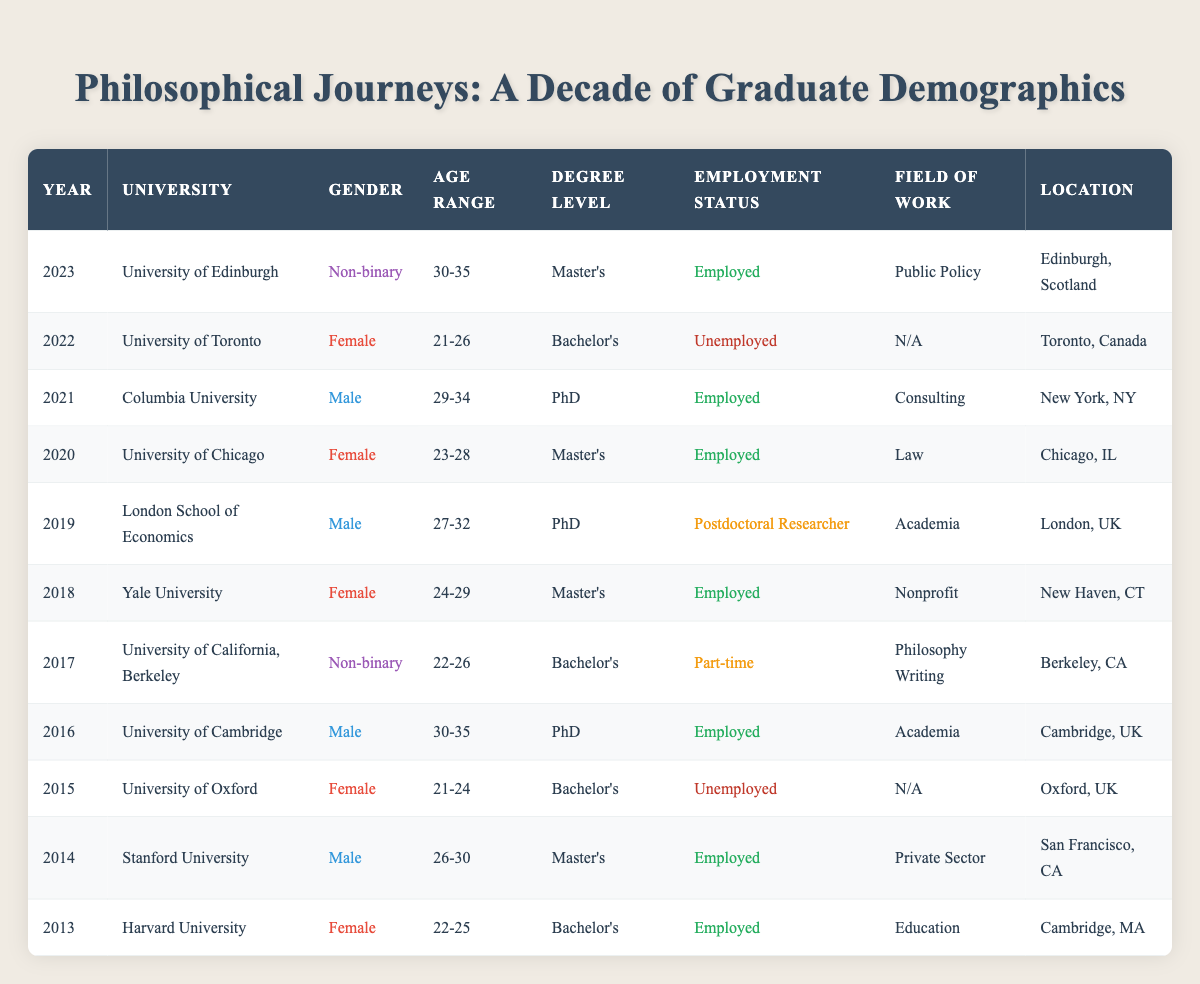What is the employment status of the University of Chicago graduate in 2020? The table shows that the graduate from the University of Chicago in 2020 has an employment status listed as "Employed."
Answer: Employed How many males graduated with a PhD across the given years? By reviewing the table, the males who graduated with a PhD are from the years 2016, 2019, and 2021, totaling 3 males.
Answer: 3 Did any female graduates report being unemployed? The table indicates that there are two female graduates reported as "Unemployed," one in 2015 and another in 2022.
Answer: Yes What field of work did the University of Toronto graduate in 2022 pursue? The graduate from the University of Toronto in 2022 is listed under "N/A" for field of work, indicating that there was no specific field reported.
Answer: N/A What is the average age range of the non-binary graduates in the provided data? The age ranges for non-binary graduates are 22-26 (2017) and 30-35 (2023). To find the average, we can convert these to numeric ranges (24 and 32.5 respectively), finding the average gives us (24 + 32.5) / 2 = 28.25, which can be rounded to show the average age range as 25-30 (approximating midpoint representation).
Answer: 25-30 Which university had a female graduate employed in law? According to the table, the University of Chicago had a female graduate in 2020 employed in the field of Law.
Answer: University of Chicago Are there any graduates who identified as non-binary that are unemployed? The table indicates that both instances of non-binary graduates (2017 and 2023) are employed, meaning there are no cases of non-binary graduates who are unemployed.
Answer: No Which university had the earliest graduating female, and what was her age range? The earliest female graduate listed is from Harvard University in 2013, with an age range of 22-25.
Answer: Harvard University, 22-25 How many graduates in total were reported as unemployed? By examining the table, we find two graduates categorized as unemployed: one female from the University of Oxford in 2015 and another female from the University of Toronto in 2022, making a total of 2 unemployed graduates.
Answer: 2 